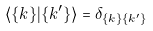<formula> <loc_0><loc_0><loc_500><loc_500>\langle \{ k \} | \{ k ^ { \prime } \} \rangle = \delta _ { \{ k \} \{ k ^ { \prime } \} }</formula> 